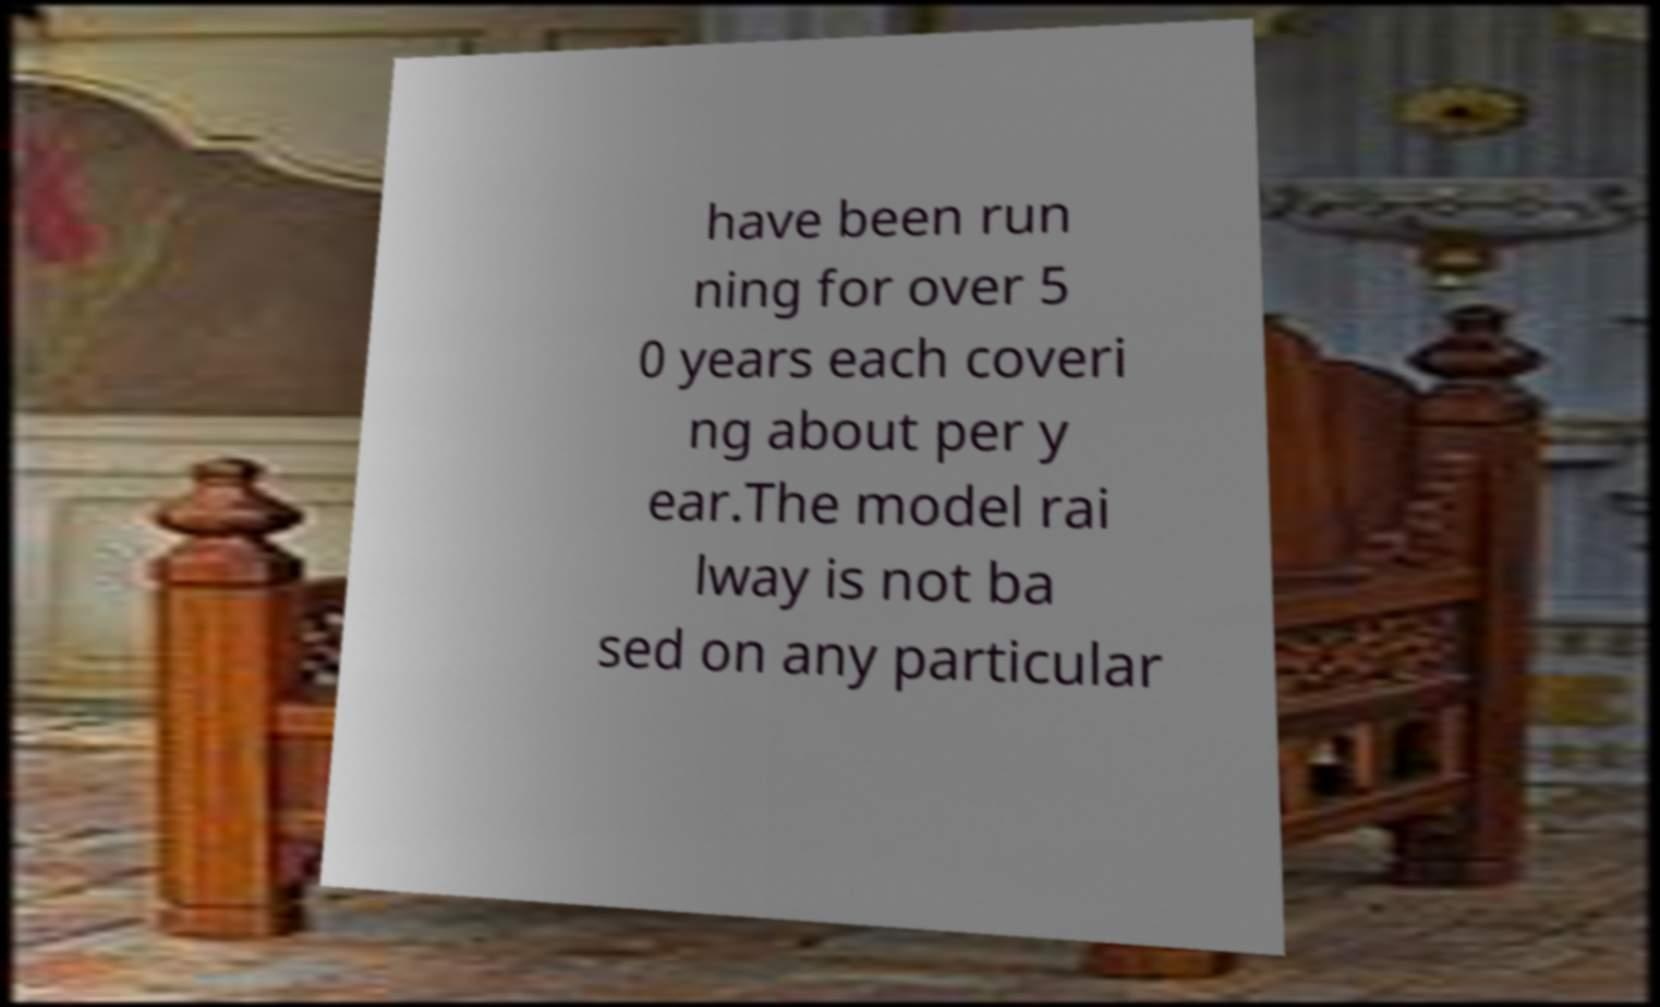For documentation purposes, I need the text within this image transcribed. Could you provide that? have been run ning for over 5 0 years each coveri ng about per y ear.The model rai lway is not ba sed on any particular 